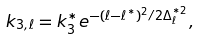<formula> <loc_0><loc_0><loc_500><loc_500>k _ { 3 , \ell } = k _ { 3 } ^ { * } e ^ { - ( \ell - \ell ^ { * } ) ^ { 2 } / 2 \Delta ^ { * 2 } _ { \ell } } ,</formula> 